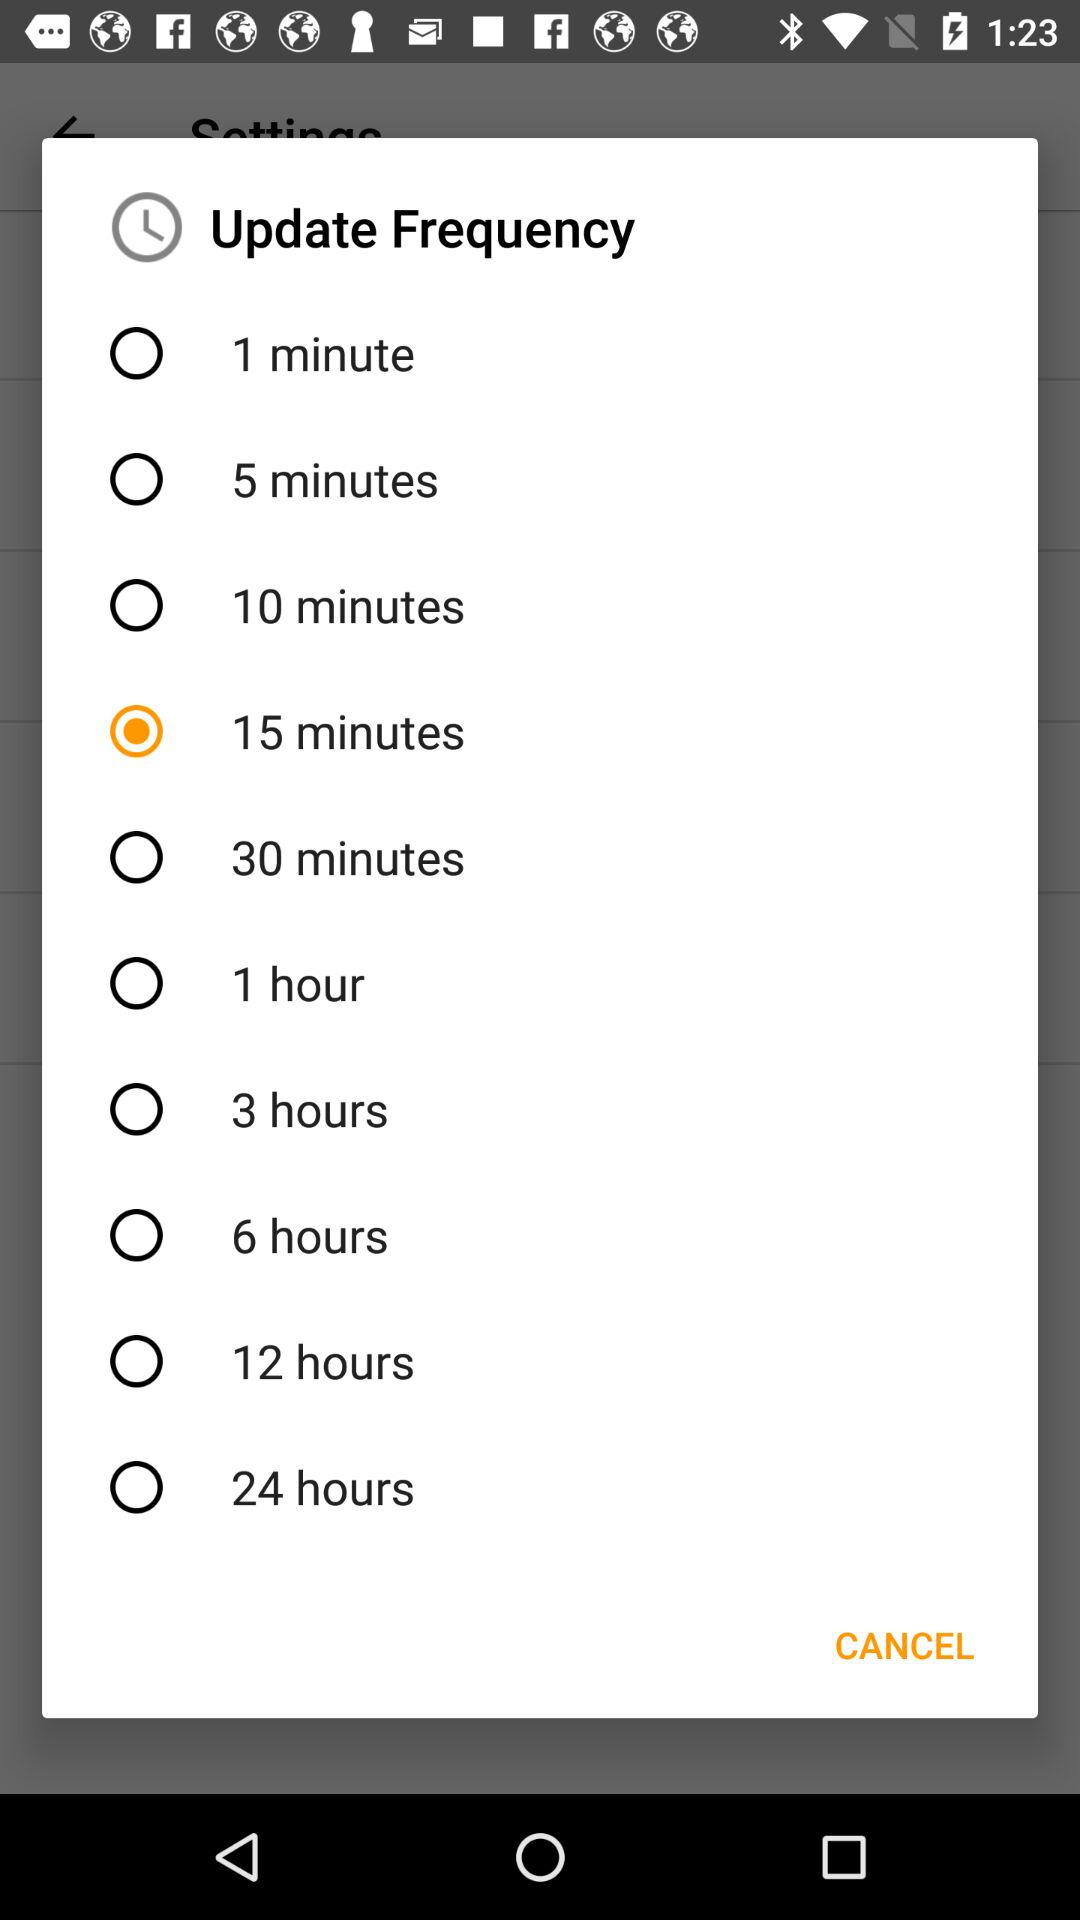Which option has been selected? The selected option is "15 minutes". 